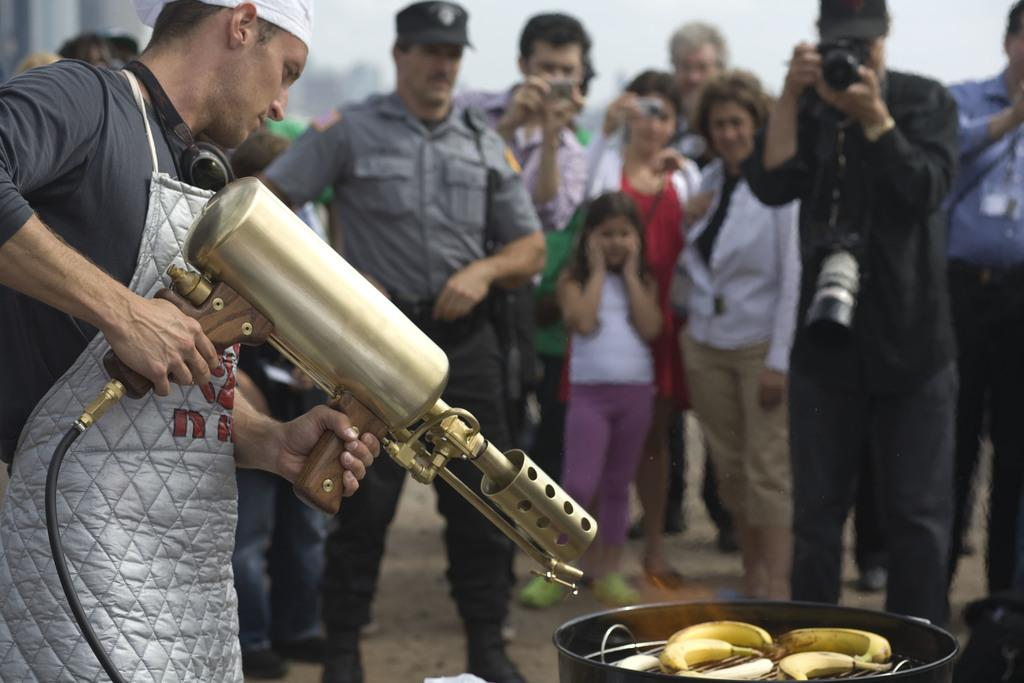What is the person in the image holding? The person in the image is holding a machine. What can be seen in the image besides the person holding the machine? There is a grill stove in the image, and bananas are on the grill stove. What is happening in the background of the image? There are people standing in the background of the image, and some of them are holding cameras. What type of beast can be seen roaming in the background of the image? There is no beast present in the image; it only features a person holding a machine, a grill stove with bananas, and people in the background, some of whom are holding cameras. 